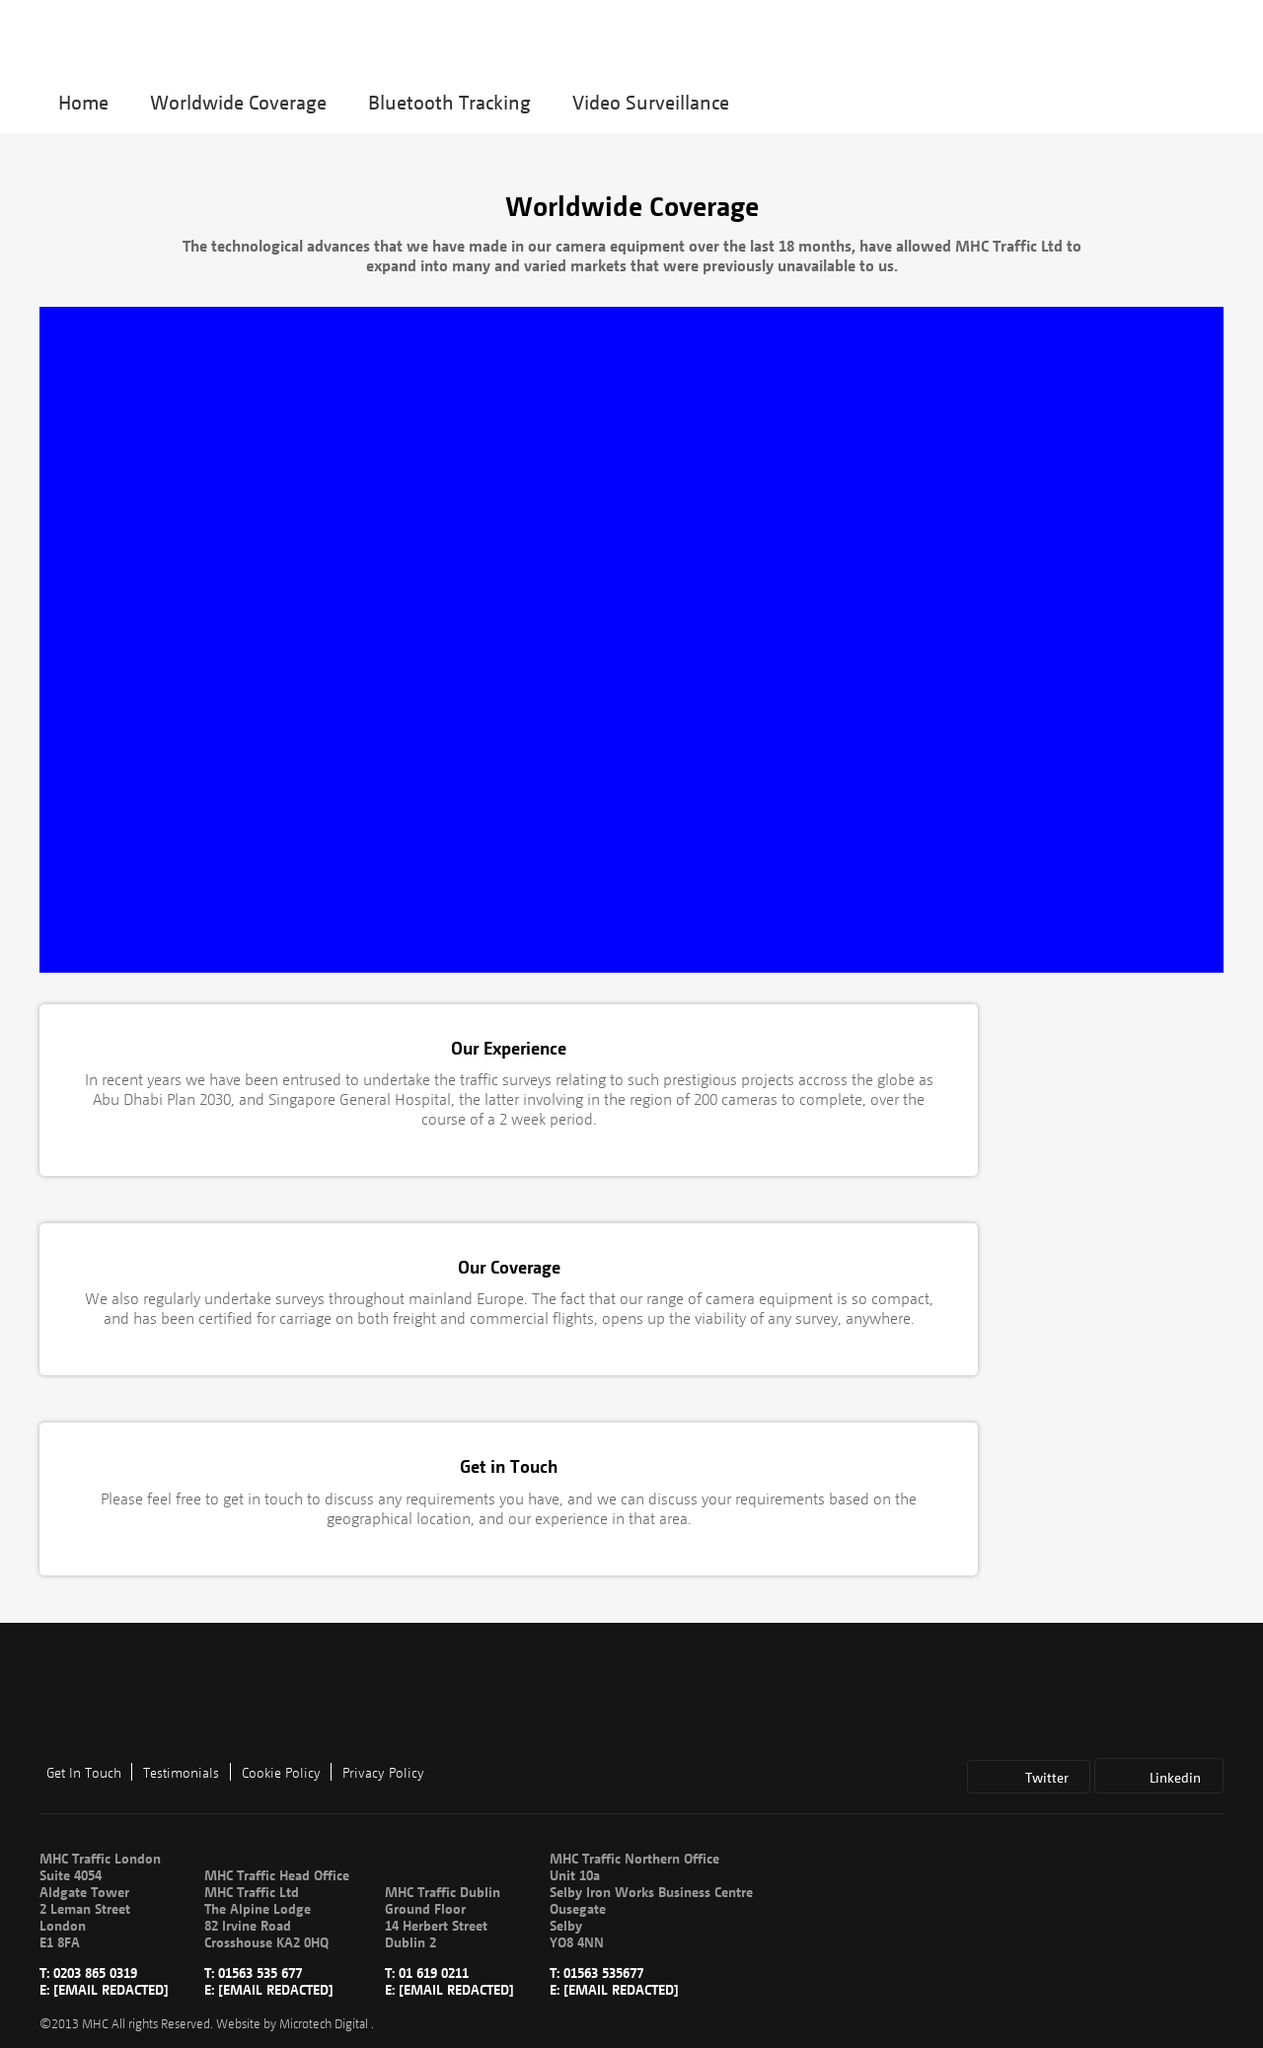How can I start building this website with HTML from the ground up? To start building a website with HTML from the ground up, you should begin by learning the basic structure. Start with a simple HTML document: 

<!DOCTYPE html>
<html>
<head>
    <title>Your Website Title</title>
</head>
<body>
    <h1>Hello, World!</h1>
    <p>Welcome to my first webpage.</p>
</body>
</html>

This code defines a basic webpage with a header and a paragraph. From here, you can start exploring more HTML tags and attributes to add more elements like images, lists, forms, etc., and gradually progress to adding CSS for styling. 